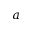<formula> <loc_0><loc_0><loc_500><loc_500>a</formula> 